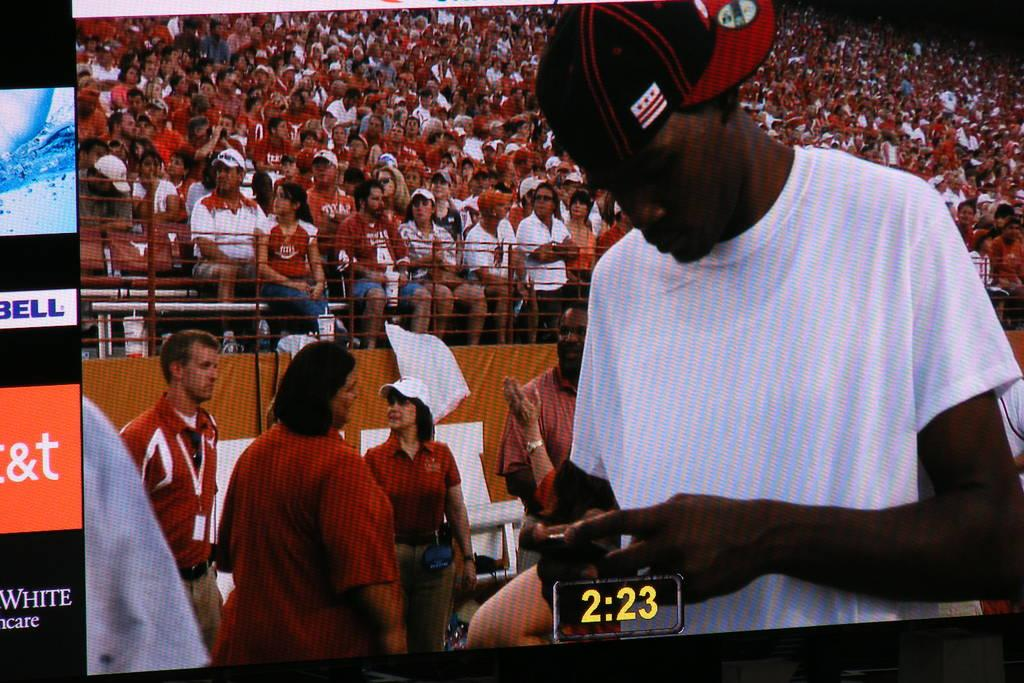Provide a one-sentence caption for the provided image. A man is on screen looking at his phone, and "2:23" is displayed beneath him. 